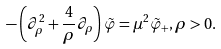Convert formula to latex. <formula><loc_0><loc_0><loc_500><loc_500>- \left ( \partial _ { \rho } ^ { 2 } + \frac { 4 } { \rho } \partial _ { \rho } \right ) \tilde { \varphi } = \mu ^ { 2 } \tilde { \varphi } _ { + } , \rho > 0 .</formula> 